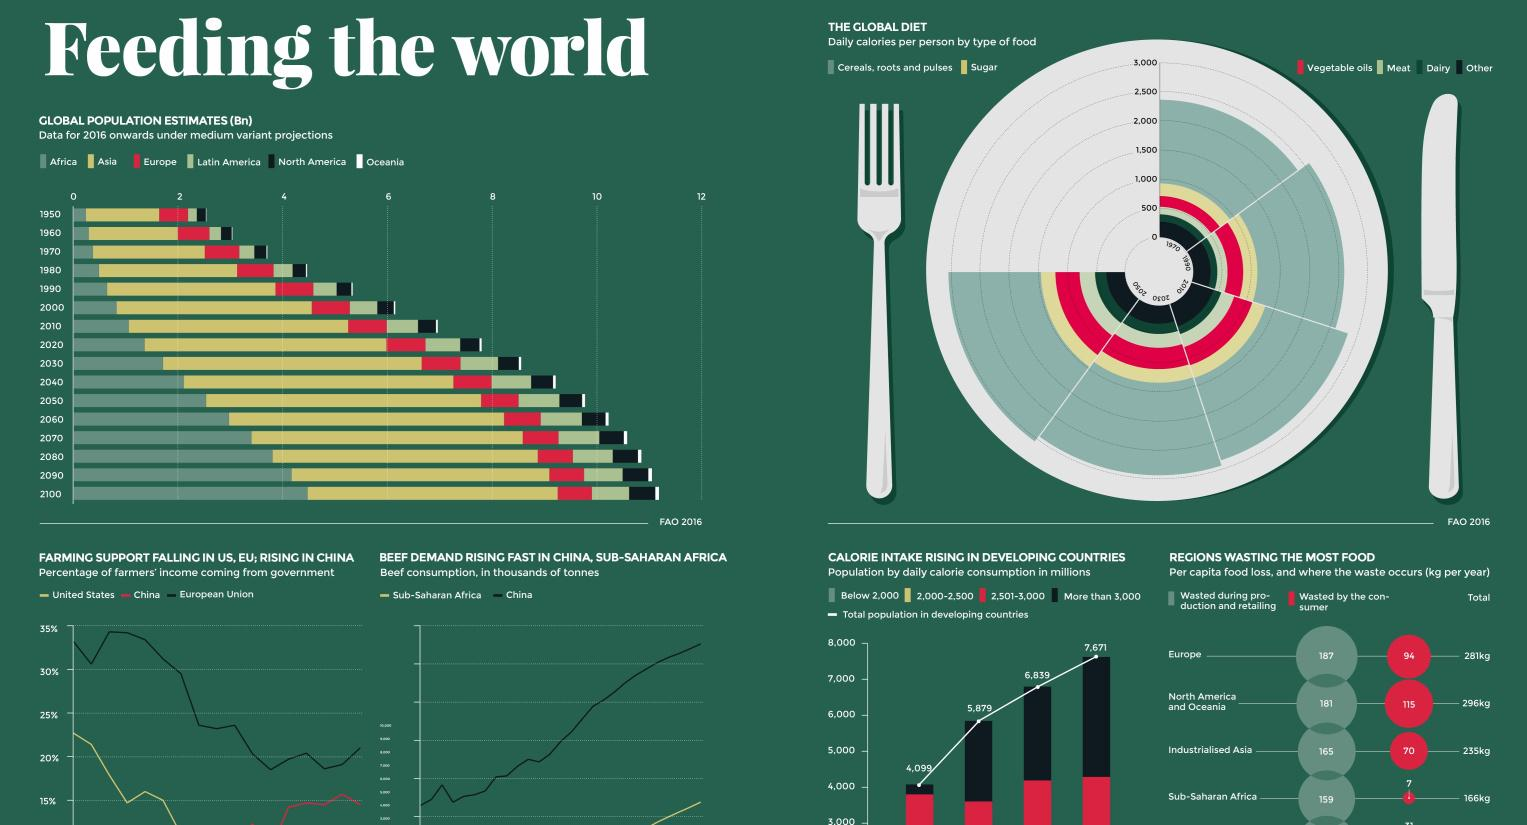Give some essential details in this illustration. It is projected that by the year 2050, the average daily caloric intake per person will exceed 3000 calories. The estimated total global population is expected to reach 10 billion by the year 2060. During the 1970s, the average daily caloric intake per person was below 2500 calories. 